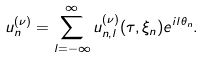<formula> <loc_0><loc_0><loc_500><loc_500>u _ { n } ^ { ( \nu ) } = \sum _ { l = - \infty } ^ { \infty } u _ { n , l } ^ { ( \nu ) } ( \tau , \xi _ { n } ) e ^ { i l \theta _ { n } } .</formula> 